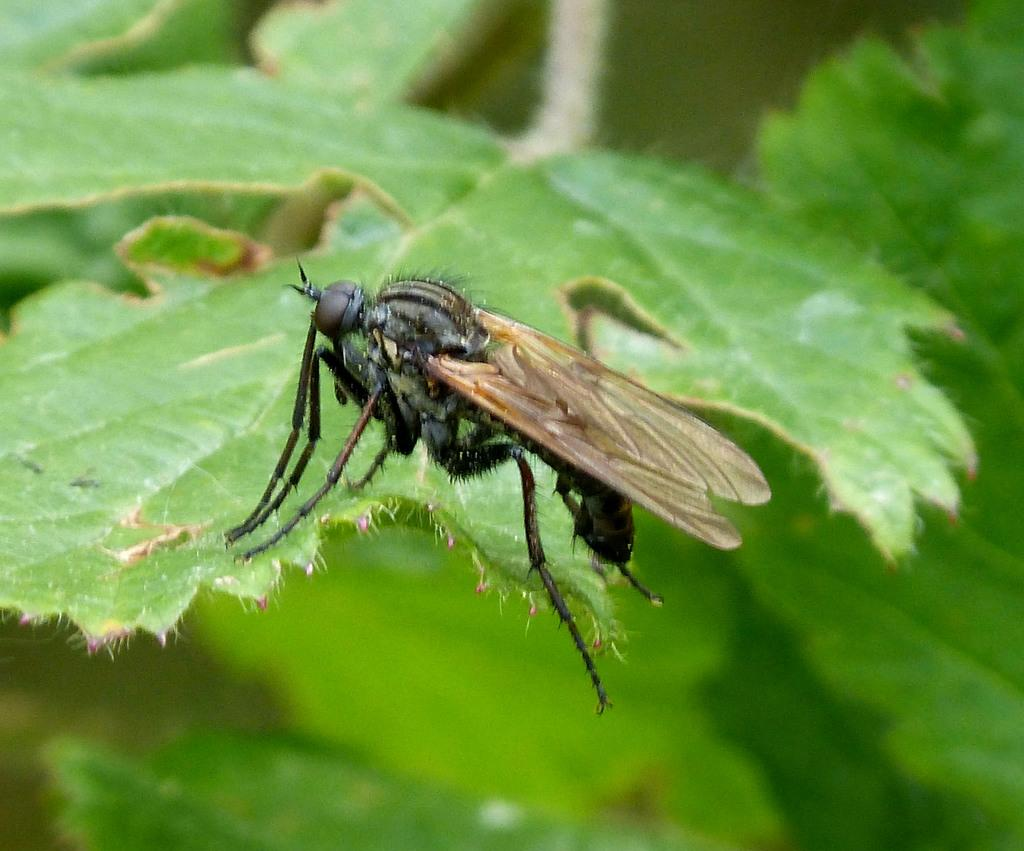What is present in the image? There is a plant in the image. Can you describe the plant in more detail? An insect is sitting on a leaf of the plant. What type of war is being fought on the plant in the image? There is no war present in the image; it features a plant with an insect on a leaf. Can you provide a guide on how to handle the flesh of the plant in the image? There is no flesh present in the image, as it is a plant with an insect on a leaf. 